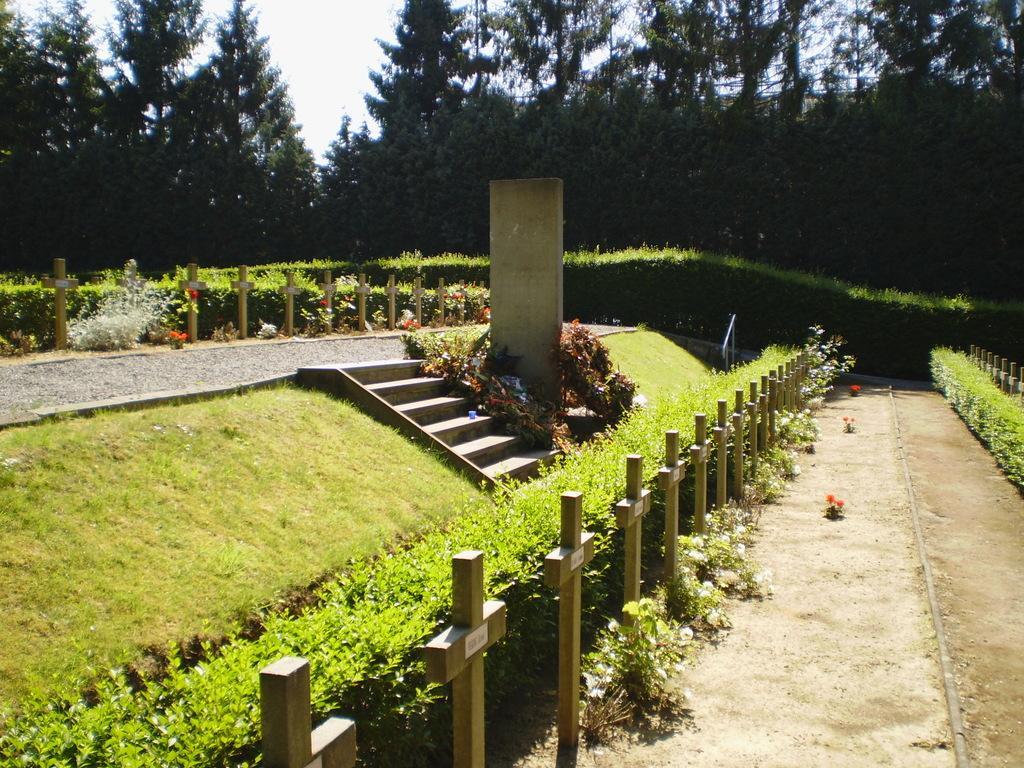Could you give a brief overview of what you see in this image? In this picture I can see the stairs, beside that I can see the plant and grass. At the top I can see the sky and clouds. 